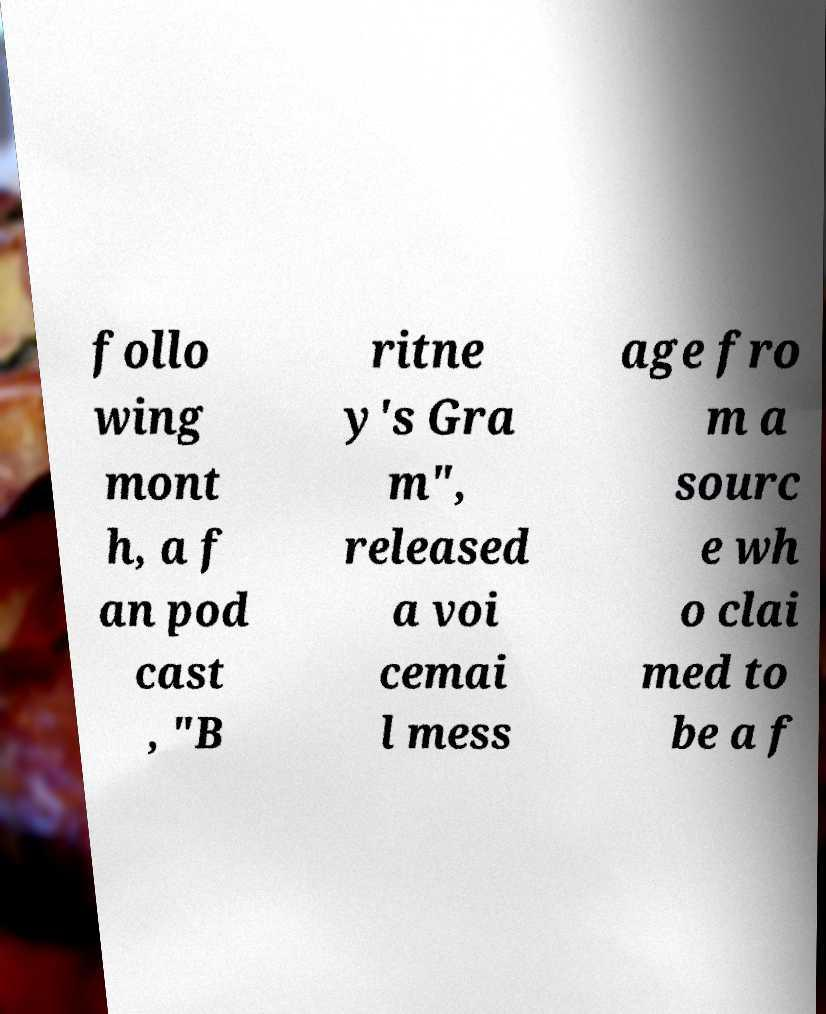Can you read and provide the text displayed in the image?This photo seems to have some interesting text. Can you extract and type it out for me? follo wing mont h, a f an pod cast , "B ritne y's Gra m", released a voi cemai l mess age fro m a sourc e wh o clai med to be a f 